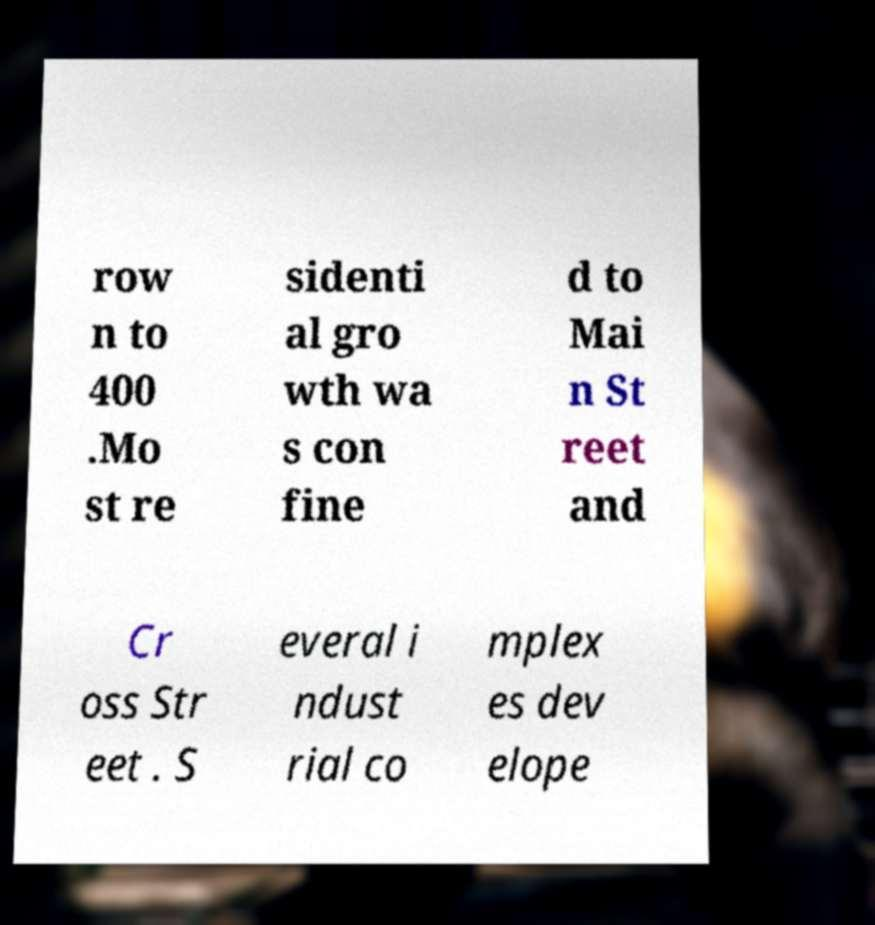There's text embedded in this image that I need extracted. Can you transcribe it verbatim? row n to 400 .Mo st re sidenti al gro wth wa s con fine d to Mai n St reet and Cr oss Str eet . S everal i ndust rial co mplex es dev elope 